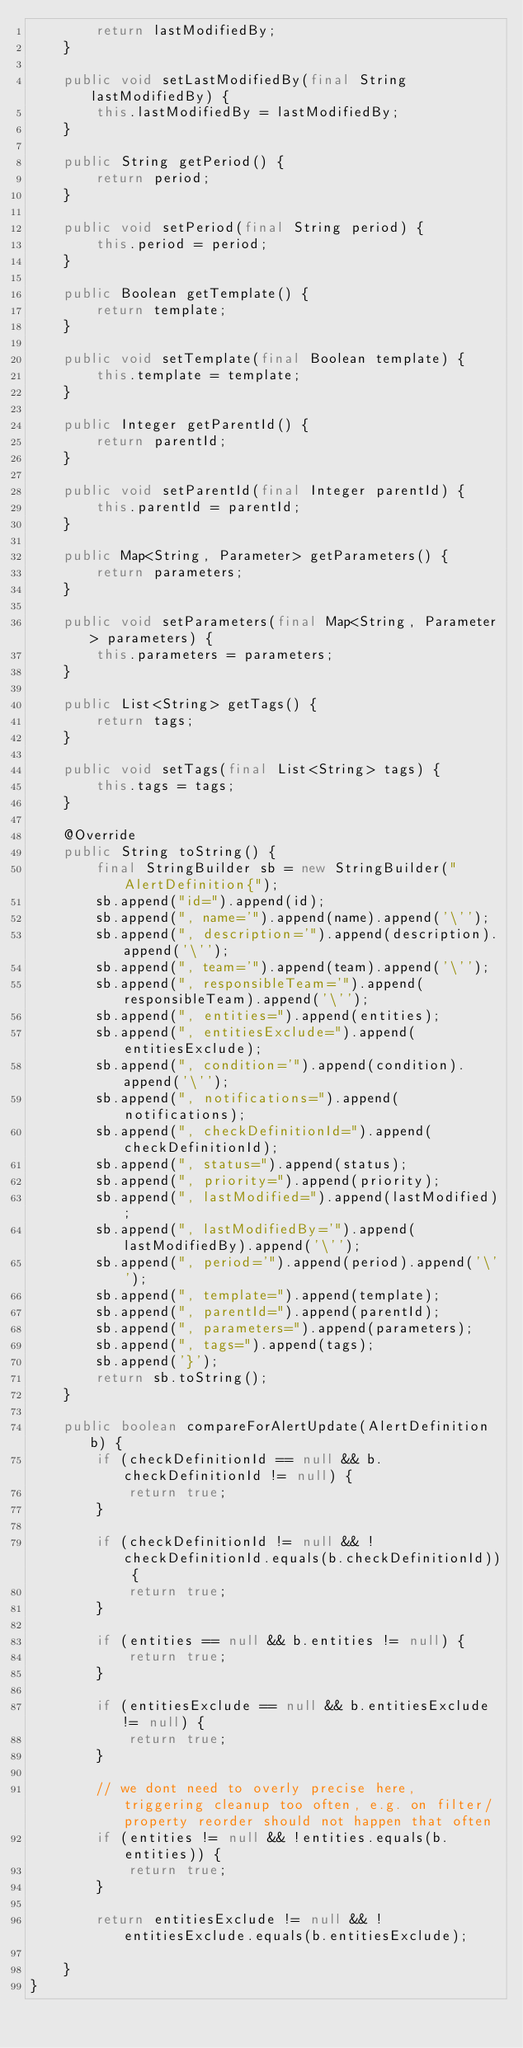<code> <loc_0><loc_0><loc_500><loc_500><_Java_>        return lastModifiedBy;
    }

    public void setLastModifiedBy(final String lastModifiedBy) {
        this.lastModifiedBy = lastModifiedBy;
    }

    public String getPeriod() {
        return period;
    }

    public void setPeriod(final String period) {
        this.period = period;
    }

    public Boolean getTemplate() {
        return template;
    }

    public void setTemplate(final Boolean template) {
        this.template = template;
    }

    public Integer getParentId() {
        return parentId;
    }

    public void setParentId(final Integer parentId) {
        this.parentId = parentId;
    }

    public Map<String, Parameter> getParameters() {
        return parameters;
    }

    public void setParameters(final Map<String, Parameter> parameters) {
        this.parameters = parameters;
    }

    public List<String> getTags() {
        return tags;
    }

    public void setTags(final List<String> tags) {
        this.tags = tags;
    }

    @Override
    public String toString() {
        final StringBuilder sb = new StringBuilder("AlertDefinition{");
        sb.append("id=").append(id);
        sb.append(", name='").append(name).append('\'');
        sb.append(", description='").append(description).append('\'');
        sb.append(", team='").append(team).append('\'');
        sb.append(", responsibleTeam='").append(responsibleTeam).append('\'');
        sb.append(", entities=").append(entities);
        sb.append(", entitiesExclude=").append(entitiesExclude);
        sb.append(", condition='").append(condition).append('\'');
        sb.append(", notifications=").append(notifications);
        sb.append(", checkDefinitionId=").append(checkDefinitionId);
        sb.append(", status=").append(status);
        sb.append(", priority=").append(priority);
        sb.append(", lastModified=").append(lastModified);
        sb.append(", lastModifiedBy='").append(lastModifiedBy).append('\'');
        sb.append(", period='").append(period).append('\'');
        sb.append(", template=").append(template);
        sb.append(", parentId=").append(parentId);
        sb.append(", parameters=").append(parameters);
        sb.append(", tags=").append(tags);
        sb.append('}');
        return sb.toString();
    }

    public boolean compareForAlertUpdate(AlertDefinition b) {
        if (checkDefinitionId == null && b.checkDefinitionId != null) {
            return true;
        }

        if (checkDefinitionId != null && !checkDefinitionId.equals(b.checkDefinitionId)) {
            return true;
        }

        if (entities == null && b.entities != null) {
            return true;
        }

        if (entitiesExclude == null && b.entitiesExclude != null) {
            return true;
        }

        // we dont need to overly precise here, triggering cleanup too often, e.g. on filter/property reorder should not happen that often
        if (entities != null && !entities.equals(b.entities)) {
            return true;
        }

        return entitiesExclude != null && !entitiesExclude.equals(b.entitiesExclude);

    }
}
</code> 